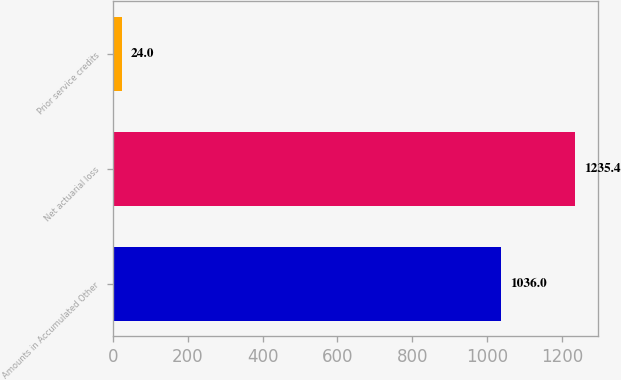Convert chart to OTSL. <chart><loc_0><loc_0><loc_500><loc_500><bar_chart><fcel>Amounts in Accumulated Other<fcel>Net actuarial loss<fcel>Prior service credits<nl><fcel>1036<fcel>1235.4<fcel>24<nl></chart> 